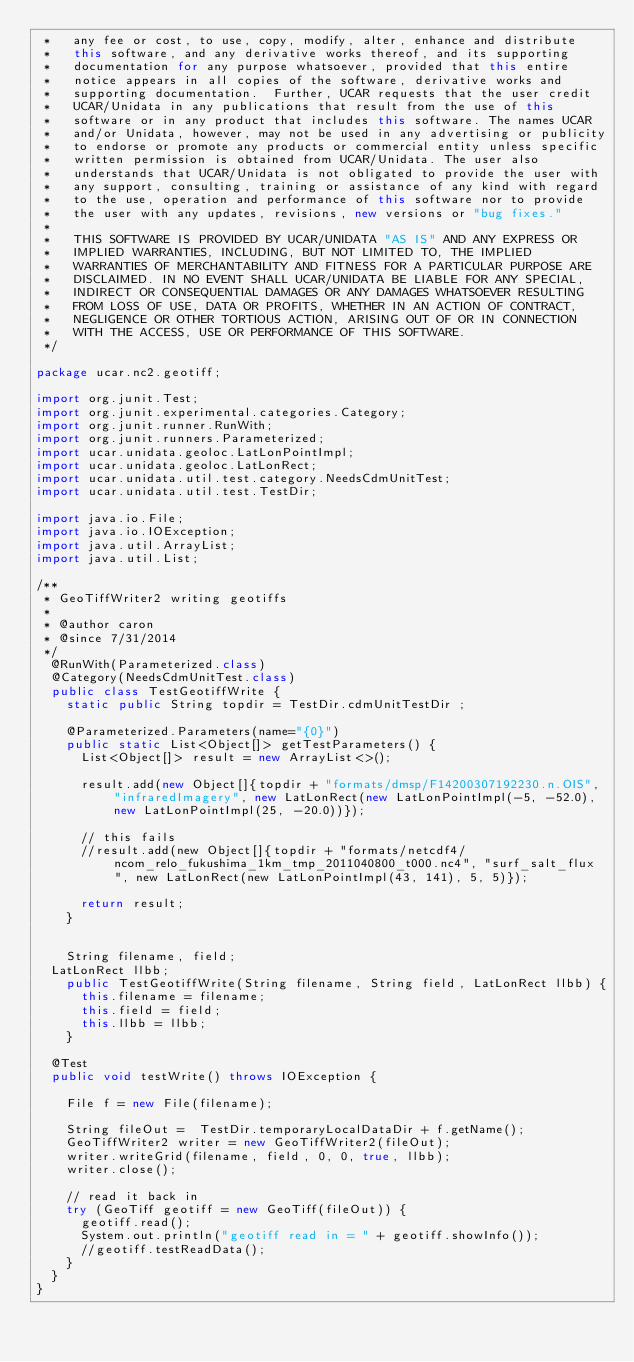<code> <loc_0><loc_0><loc_500><loc_500><_Java_> *   any fee or cost, to use, copy, modify, alter, enhance and distribute
 *   this software, and any derivative works thereof, and its supporting
 *   documentation for any purpose whatsoever, provided that this entire
 *   notice appears in all copies of the software, derivative works and
 *   supporting documentation.  Further, UCAR requests that the user credit
 *   UCAR/Unidata in any publications that result from the use of this
 *   software or in any product that includes this software. The names UCAR
 *   and/or Unidata, however, may not be used in any advertising or publicity
 *   to endorse or promote any products or commercial entity unless specific
 *   written permission is obtained from UCAR/Unidata. The user also
 *   understands that UCAR/Unidata is not obligated to provide the user with
 *   any support, consulting, training or assistance of any kind with regard
 *   to the use, operation and performance of this software nor to provide
 *   the user with any updates, revisions, new versions or "bug fixes."
 *
 *   THIS SOFTWARE IS PROVIDED BY UCAR/UNIDATA "AS IS" AND ANY EXPRESS OR
 *   IMPLIED WARRANTIES, INCLUDING, BUT NOT LIMITED TO, THE IMPLIED
 *   WARRANTIES OF MERCHANTABILITY AND FITNESS FOR A PARTICULAR PURPOSE ARE
 *   DISCLAIMED. IN NO EVENT SHALL UCAR/UNIDATA BE LIABLE FOR ANY SPECIAL,
 *   INDIRECT OR CONSEQUENTIAL DAMAGES OR ANY DAMAGES WHATSOEVER RESULTING
 *   FROM LOSS OF USE, DATA OR PROFITS, WHETHER IN AN ACTION OF CONTRACT,
 *   NEGLIGENCE OR OTHER TORTIOUS ACTION, ARISING OUT OF OR IN CONNECTION
 *   WITH THE ACCESS, USE OR PERFORMANCE OF THIS SOFTWARE.
 */

package ucar.nc2.geotiff;

import org.junit.Test;
import org.junit.experimental.categories.Category;
import org.junit.runner.RunWith;
import org.junit.runners.Parameterized;
import ucar.unidata.geoloc.LatLonPointImpl;
import ucar.unidata.geoloc.LatLonRect;
import ucar.unidata.util.test.category.NeedsCdmUnitTest;
import ucar.unidata.util.test.TestDir;

import java.io.File;
import java.io.IOException;
import java.util.ArrayList;
import java.util.List;

/**
 * GeoTiffWriter2 writing geotiffs
 *
 * @author caron
 * @since 7/31/2014
 */
  @RunWith(Parameterized.class)
  @Category(NeedsCdmUnitTest.class)
  public class TestGeotiffWrite {
    static public String topdir = TestDir.cdmUnitTestDir ;

    @Parameterized.Parameters(name="{0}")
    public static List<Object[]> getTestParameters() {
      List<Object[]> result = new ArrayList<>();

      result.add(new Object[]{topdir + "formats/dmsp/F14200307192230.n.OIS", "infraredImagery", new LatLonRect(new LatLonPointImpl(-5, -52.0), new LatLonPointImpl(25, -20.0))});

      // this fails
      //result.add(new Object[]{topdir + "formats/netcdf4/ncom_relo_fukushima_1km_tmp_2011040800_t000.nc4", "surf_salt_flux", new LatLonRect(new LatLonPointImpl(43, 141), 5, 5)});

      return result;
    }


    String filename, field;
  LatLonRect llbb;
    public TestGeotiffWrite(String filename, String field, LatLonRect llbb) {
      this.filename = filename;
      this.field = field;
      this.llbb = llbb;
    }

  @Test
  public void testWrite() throws IOException {

    File f = new File(filename);

    String fileOut =  TestDir.temporaryLocalDataDir + f.getName();
    GeoTiffWriter2 writer = new GeoTiffWriter2(fileOut);
    writer.writeGrid(filename, field, 0, 0, true, llbb);
    writer.close();

    // read it back in
    try (GeoTiff geotiff = new GeoTiff(fileOut)) {
      geotiff.read();
      System.out.println("geotiff read in = " + geotiff.showInfo());
      //geotiff.testReadData();
    }
  }
}
</code> 